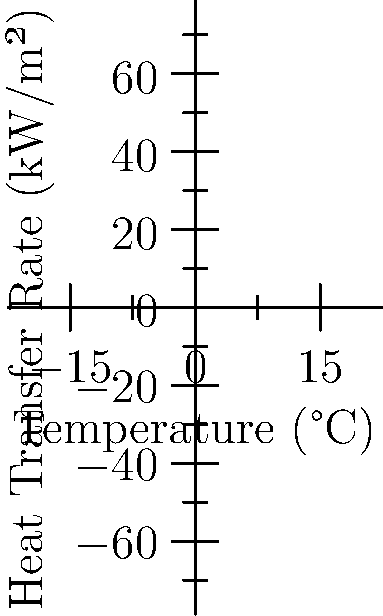As a boutique clothing brand owner, you're considering different fabric dyeing processes. The graph shows the heat transfer rate for three dyeing methods: jet, paddle, and beam dyeing. At what temperature does the heat transfer rate for jet dyeing exceed 150 kW/m²? To solve this problem, we need to follow these steps:

1. Identify the equation for jet dyeing from the graph:
   The heat transfer rate ($Q$) for jet dyeing is given by $Q = 0.02T^2$, where $T$ is the temperature in °C.

2. Set up the equation to find the temperature where $Q = 150$ kW/m²:
   $150 = 0.02T^2$

3. Solve for $T$:
   $T^2 = 150 / 0.02 = 7500$
   $T = \sqrt{7500} \approx 86.6$ °C

4. Round to the nearest whole number:
   $T \approx 87$ °C

Therefore, the heat transfer rate for jet dyeing exceeds 150 kW/m² at approximately 87°C.
Answer: 87°C 